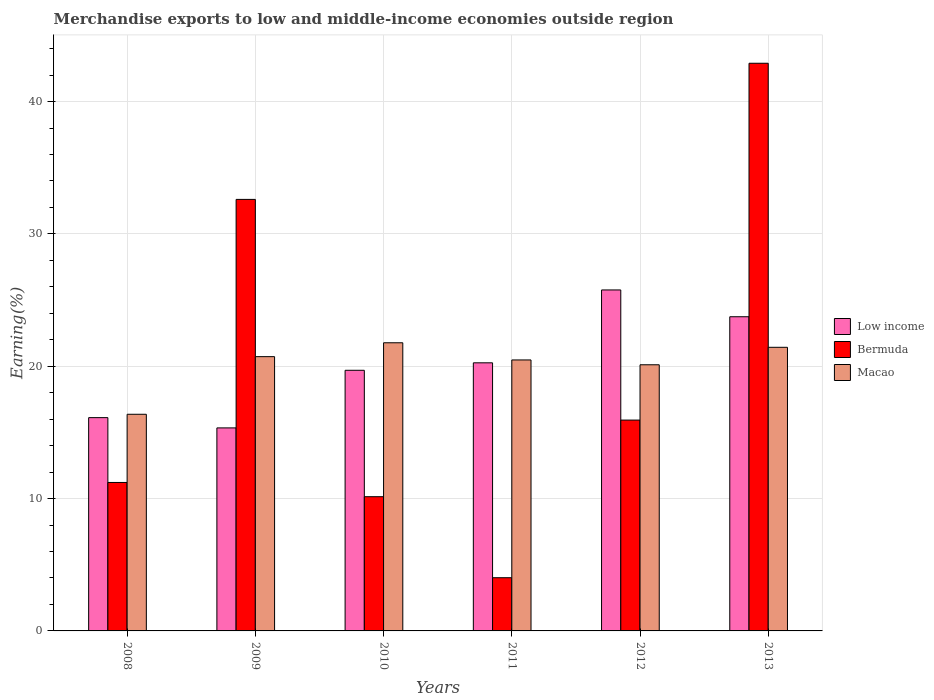How many different coloured bars are there?
Provide a succinct answer. 3. How many groups of bars are there?
Offer a very short reply. 6. Are the number of bars per tick equal to the number of legend labels?
Keep it short and to the point. Yes. Are the number of bars on each tick of the X-axis equal?
Ensure brevity in your answer.  Yes. How many bars are there on the 2nd tick from the right?
Your answer should be compact. 3. What is the label of the 2nd group of bars from the left?
Offer a very short reply. 2009. What is the percentage of amount earned from merchandise exports in Macao in 2008?
Provide a short and direct response. 16.37. Across all years, what is the maximum percentage of amount earned from merchandise exports in Macao?
Offer a terse response. 21.77. Across all years, what is the minimum percentage of amount earned from merchandise exports in Bermuda?
Make the answer very short. 4.02. What is the total percentage of amount earned from merchandise exports in Macao in the graph?
Ensure brevity in your answer.  120.89. What is the difference between the percentage of amount earned from merchandise exports in Bermuda in 2010 and that in 2013?
Your response must be concise. -32.75. What is the difference between the percentage of amount earned from merchandise exports in Bermuda in 2009 and the percentage of amount earned from merchandise exports in Low income in 2013?
Ensure brevity in your answer.  8.87. What is the average percentage of amount earned from merchandise exports in Macao per year?
Keep it short and to the point. 20.15. In the year 2011, what is the difference between the percentage of amount earned from merchandise exports in Bermuda and percentage of amount earned from merchandise exports in Low income?
Your response must be concise. -16.24. What is the ratio of the percentage of amount earned from merchandise exports in Low income in 2009 to that in 2013?
Offer a very short reply. 0.65. Is the percentage of amount earned from merchandise exports in Macao in 2010 less than that in 2012?
Your answer should be compact. No. Is the difference between the percentage of amount earned from merchandise exports in Bermuda in 2009 and 2012 greater than the difference between the percentage of amount earned from merchandise exports in Low income in 2009 and 2012?
Provide a short and direct response. Yes. What is the difference between the highest and the second highest percentage of amount earned from merchandise exports in Low income?
Your answer should be very brief. 2.03. What is the difference between the highest and the lowest percentage of amount earned from merchandise exports in Low income?
Your response must be concise. 10.42. In how many years, is the percentage of amount earned from merchandise exports in Bermuda greater than the average percentage of amount earned from merchandise exports in Bermuda taken over all years?
Your answer should be very brief. 2. Is the sum of the percentage of amount earned from merchandise exports in Bermuda in 2008 and 2009 greater than the maximum percentage of amount earned from merchandise exports in Macao across all years?
Keep it short and to the point. Yes. What does the 2nd bar from the left in 2011 represents?
Provide a succinct answer. Bermuda. Is it the case that in every year, the sum of the percentage of amount earned from merchandise exports in Low income and percentage of amount earned from merchandise exports in Macao is greater than the percentage of amount earned from merchandise exports in Bermuda?
Make the answer very short. Yes. How many years are there in the graph?
Your response must be concise. 6. Does the graph contain grids?
Provide a short and direct response. Yes. Where does the legend appear in the graph?
Your response must be concise. Center right. How many legend labels are there?
Offer a terse response. 3. How are the legend labels stacked?
Offer a very short reply. Vertical. What is the title of the graph?
Your answer should be compact. Merchandise exports to low and middle-income economies outside region. Does "Seychelles" appear as one of the legend labels in the graph?
Your answer should be compact. No. What is the label or title of the X-axis?
Your answer should be compact. Years. What is the label or title of the Y-axis?
Your answer should be very brief. Earning(%). What is the Earning(%) in Low income in 2008?
Offer a terse response. 16.12. What is the Earning(%) in Bermuda in 2008?
Your answer should be compact. 11.22. What is the Earning(%) in Macao in 2008?
Keep it short and to the point. 16.37. What is the Earning(%) of Low income in 2009?
Your answer should be compact. 15.34. What is the Earning(%) in Bermuda in 2009?
Your answer should be compact. 32.61. What is the Earning(%) of Macao in 2009?
Offer a terse response. 20.73. What is the Earning(%) in Low income in 2010?
Offer a very short reply. 19.69. What is the Earning(%) in Bermuda in 2010?
Provide a short and direct response. 10.14. What is the Earning(%) in Macao in 2010?
Keep it short and to the point. 21.77. What is the Earning(%) of Low income in 2011?
Your answer should be compact. 20.26. What is the Earning(%) in Bermuda in 2011?
Provide a succinct answer. 4.02. What is the Earning(%) of Macao in 2011?
Ensure brevity in your answer.  20.48. What is the Earning(%) in Low income in 2012?
Your response must be concise. 25.77. What is the Earning(%) of Bermuda in 2012?
Your response must be concise. 15.93. What is the Earning(%) in Macao in 2012?
Provide a succinct answer. 20.11. What is the Earning(%) in Low income in 2013?
Your answer should be very brief. 23.74. What is the Earning(%) of Bermuda in 2013?
Provide a succinct answer. 42.9. What is the Earning(%) in Macao in 2013?
Provide a succinct answer. 21.43. Across all years, what is the maximum Earning(%) in Low income?
Offer a very short reply. 25.77. Across all years, what is the maximum Earning(%) of Bermuda?
Give a very brief answer. 42.9. Across all years, what is the maximum Earning(%) in Macao?
Your answer should be compact. 21.77. Across all years, what is the minimum Earning(%) in Low income?
Provide a short and direct response. 15.34. Across all years, what is the minimum Earning(%) in Bermuda?
Keep it short and to the point. 4.02. Across all years, what is the minimum Earning(%) in Macao?
Keep it short and to the point. 16.37. What is the total Earning(%) of Low income in the graph?
Make the answer very short. 120.92. What is the total Earning(%) in Bermuda in the graph?
Your answer should be very brief. 116.82. What is the total Earning(%) of Macao in the graph?
Offer a terse response. 120.89. What is the difference between the Earning(%) in Low income in 2008 and that in 2009?
Your response must be concise. 0.78. What is the difference between the Earning(%) in Bermuda in 2008 and that in 2009?
Provide a short and direct response. -21.39. What is the difference between the Earning(%) in Macao in 2008 and that in 2009?
Keep it short and to the point. -4.36. What is the difference between the Earning(%) of Low income in 2008 and that in 2010?
Keep it short and to the point. -3.58. What is the difference between the Earning(%) in Bermuda in 2008 and that in 2010?
Make the answer very short. 1.08. What is the difference between the Earning(%) of Macao in 2008 and that in 2010?
Keep it short and to the point. -5.4. What is the difference between the Earning(%) of Low income in 2008 and that in 2011?
Your answer should be compact. -4.14. What is the difference between the Earning(%) in Bermuda in 2008 and that in 2011?
Make the answer very short. 7.2. What is the difference between the Earning(%) of Macao in 2008 and that in 2011?
Offer a very short reply. -4.11. What is the difference between the Earning(%) in Low income in 2008 and that in 2012?
Keep it short and to the point. -9.65. What is the difference between the Earning(%) in Bermuda in 2008 and that in 2012?
Keep it short and to the point. -4.71. What is the difference between the Earning(%) in Macao in 2008 and that in 2012?
Your answer should be very brief. -3.74. What is the difference between the Earning(%) in Low income in 2008 and that in 2013?
Offer a very short reply. -7.62. What is the difference between the Earning(%) in Bermuda in 2008 and that in 2013?
Your answer should be very brief. -31.68. What is the difference between the Earning(%) of Macao in 2008 and that in 2013?
Provide a succinct answer. -5.06. What is the difference between the Earning(%) in Low income in 2009 and that in 2010?
Keep it short and to the point. -4.35. What is the difference between the Earning(%) of Bermuda in 2009 and that in 2010?
Keep it short and to the point. 22.47. What is the difference between the Earning(%) in Macao in 2009 and that in 2010?
Provide a succinct answer. -1.05. What is the difference between the Earning(%) in Low income in 2009 and that in 2011?
Ensure brevity in your answer.  -4.92. What is the difference between the Earning(%) in Bermuda in 2009 and that in 2011?
Give a very brief answer. 28.59. What is the difference between the Earning(%) of Macao in 2009 and that in 2011?
Provide a succinct answer. 0.25. What is the difference between the Earning(%) in Low income in 2009 and that in 2012?
Provide a short and direct response. -10.42. What is the difference between the Earning(%) in Bermuda in 2009 and that in 2012?
Your response must be concise. 16.68. What is the difference between the Earning(%) in Macao in 2009 and that in 2012?
Ensure brevity in your answer.  0.61. What is the difference between the Earning(%) of Low income in 2009 and that in 2013?
Make the answer very short. -8.4. What is the difference between the Earning(%) of Bermuda in 2009 and that in 2013?
Your answer should be compact. -10.29. What is the difference between the Earning(%) of Macao in 2009 and that in 2013?
Make the answer very short. -0.71. What is the difference between the Earning(%) in Low income in 2010 and that in 2011?
Offer a terse response. -0.57. What is the difference between the Earning(%) of Bermuda in 2010 and that in 2011?
Provide a short and direct response. 6.12. What is the difference between the Earning(%) in Macao in 2010 and that in 2011?
Offer a terse response. 1.3. What is the difference between the Earning(%) in Low income in 2010 and that in 2012?
Your answer should be compact. -6.07. What is the difference between the Earning(%) in Bermuda in 2010 and that in 2012?
Offer a very short reply. -5.79. What is the difference between the Earning(%) of Macao in 2010 and that in 2012?
Give a very brief answer. 1.66. What is the difference between the Earning(%) in Low income in 2010 and that in 2013?
Offer a terse response. -4.05. What is the difference between the Earning(%) in Bermuda in 2010 and that in 2013?
Your response must be concise. -32.75. What is the difference between the Earning(%) of Macao in 2010 and that in 2013?
Give a very brief answer. 0.34. What is the difference between the Earning(%) of Low income in 2011 and that in 2012?
Your answer should be very brief. -5.51. What is the difference between the Earning(%) of Bermuda in 2011 and that in 2012?
Offer a terse response. -11.91. What is the difference between the Earning(%) in Macao in 2011 and that in 2012?
Give a very brief answer. 0.36. What is the difference between the Earning(%) of Low income in 2011 and that in 2013?
Provide a short and direct response. -3.48. What is the difference between the Earning(%) in Bermuda in 2011 and that in 2013?
Offer a terse response. -38.88. What is the difference between the Earning(%) of Macao in 2011 and that in 2013?
Provide a succinct answer. -0.96. What is the difference between the Earning(%) of Low income in 2012 and that in 2013?
Your answer should be compact. 2.03. What is the difference between the Earning(%) in Bermuda in 2012 and that in 2013?
Offer a terse response. -26.96. What is the difference between the Earning(%) in Macao in 2012 and that in 2013?
Keep it short and to the point. -1.32. What is the difference between the Earning(%) in Low income in 2008 and the Earning(%) in Bermuda in 2009?
Give a very brief answer. -16.49. What is the difference between the Earning(%) in Low income in 2008 and the Earning(%) in Macao in 2009?
Offer a terse response. -4.61. What is the difference between the Earning(%) of Bermuda in 2008 and the Earning(%) of Macao in 2009?
Give a very brief answer. -9.51. What is the difference between the Earning(%) of Low income in 2008 and the Earning(%) of Bermuda in 2010?
Your response must be concise. 5.97. What is the difference between the Earning(%) in Low income in 2008 and the Earning(%) in Macao in 2010?
Offer a terse response. -5.66. What is the difference between the Earning(%) in Bermuda in 2008 and the Earning(%) in Macao in 2010?
Keep it short and to the point. -10.56. What is the difference between the Earning(%) of Low income in 2008 and the Earning(%) of Bermuda in 2011?
Offer a terse response. 12.1. What is the difference between the Earning(%) in Low income in 2008 and the Earning(%) in Macao in 2011?
Provide a succinct answer. -4.36. What is the difference between the Earning(%) of Bermuda in 2008 and the Earning(%) of Macao in 2011?
Provide a succinct answer. -9.26. What is the difference between the Earning(%) in Low income in 2008 and the Earning(%) in Bermuda in 2012?
Your answer should be compact. 0.19. What is the difference between the Earning(%) in Low income in 2008 and the Earning(%) in Macao in 2012?
Give a very brief answer. -3.99. What is the difference between the Earning(%) in Bermuda in 2008 and the Earning(%) in Macao in 2012?
Your answer should be compact. -8.89. What is the difference between the Earning(%) of Low income in 2008 and the Earning(%) of Bermuda in 2013?
Offer a very short reply. -26.78. What is the difference between the Earning(%) of Low income in 2008 and the Earning(%) of Macao in 2013?
Your response must be concise. -5.31. What is the difference between the Earning(%) in Bermuda in 2008 and the Earning(%) in Macao in 2013?
Your response must be concise. -10.21. What is the difference between the Earning(%) of Low income in 2009 and the Earning(%) of Bermuda in 2010?
Provide a succinct answer. 5.2. What is the difference between the Earning(%) in Low income in 2009 and the Earning(%) in Macao in 2010?
Your response must be concise. -6.43. What is the difference between the Earning(%) in Bermuda in 2009 and the Earning(%) in Macao in 2010?
Keep it short and to the point. 10.83. What is the difference between the Earning(%) in Low income in 2009 and the Earning(%) in Bermuda in 2011?
Provide a short and direct response. 11.32. What is the difference between the Earning(%) in Low income in 2009 and the Earning(%) in Macao in 2011?
Offer a terse response. -5.13. What is the difference between the Earning(%) of Bermuda in 2009 and the Earning(%) of Macao in 2011?
Give a very brief answer. 12.13. What is the difference between the Earning(%) in Low income in 2009 and the Earning(%) in Bermuda in 2012?
Give a very brief answer. -0.59. What is the difference between the Earning(%) of Low income in 2009 and the Earning(%) of Macao in 2012?
Offer a very short reply. -4.77. What is the difference between the Earning(%) of Bermuda in 2009 and the Earning(%) of Macao in 2012?
Your answer should be very brief. 12.5. What is the difference between the Earning(%) in Low income in 2009 and the Earning(%) in Bermuda in 2013?
Your answer should be compact. -27.55. What is the difference between the Earning(%) in Low income in 2009 and the Earning(%) in Macao in 2013?
Your answer should be very brief. -6.09. What is the difference between the Earning(%) in Bermuda in 2009 and the Earning(%) in Macao in 2013?
Give a very brief answer. 11.18. What is the difference between the Earning(%) of Low income in 2010 and the Earning(%) of Bermuda in 2011?
Make the answer very short. 15.67. What is the difference between the Earning(%) of Low income in 2010 and the Earning(%) of Macao in 2011?
Give a very brief answer. -0.78. What is the difference between the Earning(%) of Bermuda in 2010 and the Earning(%) of Macao in 2011?
Offer a terse response. -10.33. What is the difference between the Earning(%) of Low income in 2010 and the Earning(%) of Bermuda in 2012?
Provide a succinct answer. 3.76. What is the difference between the Earning(%) in Low income in 2010 and the Earning(%) in Macao in 2012?
Offer a terse response. -0.42. What is the difference between the Earning(%) in Bermuda in 2010 and the Earning(%) in Macao in 2012?
Offer a very short reply. -9.97. What is the difference between the Earning(%) in Low income in 2010 and the Earning(%) in Bermuda in 2013?
Ensure brevity in your answer.  -23.2. What is the difference between the Earning(%) in Low income in 2010 and the Earning(%) in Macao in 2013?
Keep it short and to the point. -1.74. What is the difference between the Earning(%) of Bermuda in 2010 and the Earning(%) of Macao in 2013?
Your answer should be very brief. -11.29. What is the difference between the Earning(%) of Low income in 2011 and the Earning(%) of Bermuda in 2012?
Make the answer very short. 4.33. What is the difference between the Earning(%) in Low income in 2011 and the Earning(%) in Macao in 2012?
Provide a succinct answer. 0.15. What is the difference between the Earning(%) in Bermuda in 2011 and the Earning(%) in Macao in 2012?
Offer a very short reply. -16.09. What is the difference between the Earning(%) of Low income in 2011 and the Earning(%) of Bermuda in 2013?
Keep it short and to the point. -22.64. What is the difference between the Earning(%) in Low income in 2011 and the Earning(%) in Macao in 2013?
Offer a terse response. -1.17. What is the difference between the Earning(%) of Bermuda in 2011 and the Earning(%) of Macao in 2013?
Provide a succinct answer. -17.41. What is the difference between the Earning(%) of Low income in 2012 and the Earning(%) of Bermuda in 2013?
Provide a short and direct response. -17.13. What is the difference between the Earning(%) in Low income in 2012 and the Earning(%) in Macao in 2013?
Provide a succinct answer. 4.33. What is the difference between the Earning(%) of Bermuda in 2012 and the Earning(%) of Macao in 2013?
Ensure brevity in your answer.  -5.5. What is the average Earning(%) of Low income per year?
Offer a terse response. 20.15. What is the average Earning(%) in Bermuda per year?
Provide a succinct answer. 19.47. What is the average Earning(%) in Macao per year?
Your response must be concise. 20.15. In the year 2008, what is the difference between the Earning(%) of Low income and Earning(%) of Bermuda?
Your answer should be compact. 4.9. In the year 2008, what is the difference between the Earning(%) of Low income and Earning(%) of Macao?
Keep it short and to the point. -0.25. In the year 2008, what is the difference between the Earning(%) in Bermuda and Earning(%) in Macao?
Make the answer very short. -5.15. In the year 2009, what is the difference between the Earning(%) of Low income and Earning(%) of Bermuda?
Your answer should be very brief. -17.27. In the year 2009, what is the difference between the Earning(%) of Low income and Earning(%) of Macao?
Ensure brevity in your answer.  -5.38. In the year 2009, what is the difference between the Earning(%) of Bermuda and Earning(%) of Macao?
Ensure brevity in your answer.  11.88. In the year 2010, what is the difference between the Earning(%) of Low income and Earning(%) of Bermuda?
Your answer should be compact. 9.55. In the year 2010, what is the difference between the Earning(%) of Low income and Earning(%) of Macao?
Ensure brevity in your answer.  -2.08. In the year 2010, what is the difference between the Earning(%) in Bermuda and Earning(%) in Macao?
Your answer should be very brief. -11.63. In the year 2011, what is the difference between the Earning(%) in Low income and Earning(%) in Bermuda?
Your response must be concise. 16.24. In the year 2011, what is the difference between the Earning(%) of Low income and Earning(%) of Macao?
Provide a succinct answer. -0.22. In the year 2011, what is the difference between the Earning(%) of Bermuda and Earning(%) of Macao?
Offer a very short reply. -16.46. In the year 2012, what is the difference between the Earning(%) in Low income and Earning(%) in Bermuda?
Offer a terse response. 9.83. In the year 2012, what is the difference between the Earning(%) in Low income and Earning(%) in Macao?
Ensure brevity in your answer.  5.66. In the year 2012, what is the difference between the Earning(%) of Bermuda and Earning(%) of Macao?
Your response must be concise. -4.18. In the year 2013, what is the difference between the Earning(%) in Low income and Earning(%) in Bermuda?
Your answer should be very brief. -19.15. In the year 2013, what is the difference between the Earning(%) in Low income and Earning(%) in Macao?
Your answer should be very brief. 2.31. In the year 2013, what is the difference between the Earning(%) of Bermuda and Earning(%) of Macao?
Provide a succinct answer. 21.46. What is the ratio of the Earning(%) in Low income in 2008 to that in 2009?
Provide a succinct answer. 1.05. What is the ratio of the Earning(%) in Bermuda in 2008 to that in 2009?
Provide a succinct answer. 0.34. What is the ratio of the Earning(%) in Macao in 2008 to that in 2009?
Provide a short and direct response. 0.79. What is the ratio of the Earning(%) of Low income in 2008 to that in 2010?
Make the answer very short. 0.82. What is the ratio of the Earning(%) in Bermuda in 2008 to that in 2010?
Offer a very short reply. 1.11. What is the ratio of the Earning(%) of Macao in 2008 to that in 2010?
Offer a terse response. 0.75. What is the ratio of the Earning(%) of Low income in 2008 to that in 2011?
Provide a short and direct response. 0.8. What is the ratio of the Earning(%) in Bermuda in 2008 to that in 2011?
Your answer should be very brief. 2.79. What is the ratio of the Earning(%) of Macao in 2008 to that in 2011?
Ensure brevity in your answer.  0.8. What is the ratio of the Earning(%) in Low income in 2008 to that in 2012?
Provide a succinct answer. 0.63. What is the ratio of the Earning(%) of Bermuda in 2008 to that in 2012?
Your answer should be compact. 0.7. What is the ratio of the Earning(%) of Macao in 2008 to that in 2012?
Offer a very short reply. 0.81. What is the ratio of the Earning(%) of Low income in 2008 to that in 2013?
Make the answer very short. 0.68. What is the ratio of the Earning(%) in Bermuda in 2008 to that in 2013?
Offer a terse response. 0.26. What is the ratio of the Earning(%) of Macao in 2008 to that in 2013?
Give a very brief answer. 0.76. What is the ratio of the Earning(%) of Low income in 2009 to that in 2010?
Give a very brief answer. 0.78. What is the ratio of the Earning(%) of Bermuda in 2009 to that in 2010?
Your answer should be very brief. 3.21. What is the ratio of the Earning(%) of Macao in 2009 to that in 2010?
Your answer should be compact. 0.95. What is the ratio of the Earning(%) in Low income in 2009 to that in 2011?
Offer a terse response. 0.76. What is the ratio of the Earning(%) of Bermuda in 2009 to that in 2011?
Offer a very short reply. 8.11. What is the ratio of the Earning(%) in Macao in 2009 to that in 2011?
Ensure brevity in your answer.  1.01. What is the ratio of the Earning(%) in Low income in 2009 to that in 2012?
Offer a terse response. 0.6. What is the ratio of the Earning(%) of Bermuda in 2009 to that in 2012?
Provide a succinct answer. 2.05. What is the ratio of the Earning(%) of Macao in 2009 to that in 2012?
Offer a terse response. 1.03. What is the ratio of the Earning(%) in Low income in 2009 to that in 2013?
Ensure brevity in your answer.  0.65. What is the ratio of the Earning(%) in Bermuda in 2009 to that in 2013?
Offer a terse response. 0.76. What is the ratio of the Earning(%) of Macao in 2009 to that in 2013?
Make the answer very short. 0.97. What is the ratio of the Earning(%) of Low income in 2010 to that in 2011?
Give a very brief answer. 0.97. What is the ratio of the Earning(%) of Bermuda in 2010 to that in 2011?
Make the answer very short. 2.52. What is the ratio of the Earning(%) of Macao in 2010 to that in 2011?
Provide a succinct answer. 1.06. What is the ratio of the Earning(%) of Low income in 2010 to that in 2012?
Your answer should be very brief. 0.76. What is the ratio of the Earning(%) in Bermuda in 2010 to that in 2012?
Give a very brief answer. 0.64. What is the ratio of the Earning(%) in Macao in 2010 to that in 2012?
Make the answer very short. 1.08. What is the ratio of the Earning(%) of Low income in 2010 to that in 2013?
Keep it short and to the point. 0.83. What is the ratio of the Earning(%) in Bermuda in 2010 to that in 2013?
Make the answer very short. 0.24. What is the ratio of the Earning(%) in Low income in 2011 to that in 2012?
Give a very brief answer. 0.79. What is the ratio of the Earning(%) of Bermuda in 2011 to that in 2012?
Offer a terse response. 0.25. What is the ratio of the Earning(%) in Macao in 2011 to that in 2012?
Keep it short and to the point. 1.02. What is the ratio of the Earning(%) in Low income in 2011 to that in 2013?
Your answer should be compact. 0.85. What is the ratio of the Earning(%) in Bermuda in 2011 to that in 2013?
Give a very brief answer. 0.09. What is the ratio of the Earning(%) of Macao in 2011 to that in 2013?
Your response must be concise. 0.96. What is the ratio of the Earning(%) in Low income in 2012 to that in 2013?
Keep it short and to the point. 1.09. What is the ratio of the Earning(%) of Bermuda in 2012 to that in 2013?
Provide a succinct answer. 0.37. What is the ratio of the Earning(%) of Macao in 2012 to that in 2013?
Your answer should be very brief. 0.94. What is the difference between the highest and the second highest Earning(%) in Low income?
Your answer should be very brief. 2.03. What is the difference between the highest and the second highest Earning(%) of Bermuda?
Provide a succinct answer. 10.29. What is the difference between the highest and the second highest Earning(%) in Macao?
Make the answer very short. 0.34. What is the difference between the highest and the lowest Earning(%) in Low income?
Keep it short and to the point. 10.42. What is the difference between the highest and the lowest Earning(%) of Bermuda?
Give a very brief answer. 38.88. What is the difference between the highest and the lowest Earning(%) in Macao?
Provide a short and direct response. 5.4. 